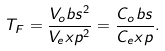<formula> <loc_0><loc_0><loc_500><loc_500>T _ { F } = \frac { V _ { o } b s ^ { 2 } } { V _ { e } x p ^ { 2 } } = \frac { C _ { o } b s } { C _ { e } x p } .</formula> 